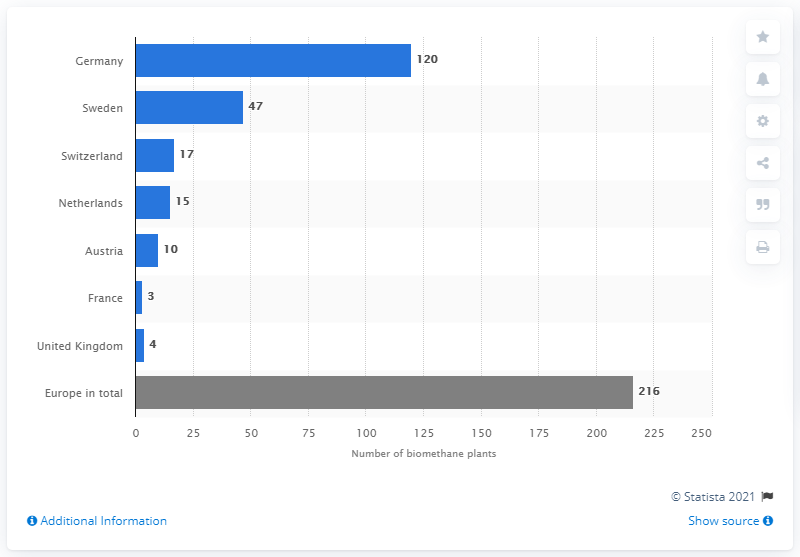Specify some key components in this picture. There were 15 operational biomethane plants in the Netherlands in 2013. 